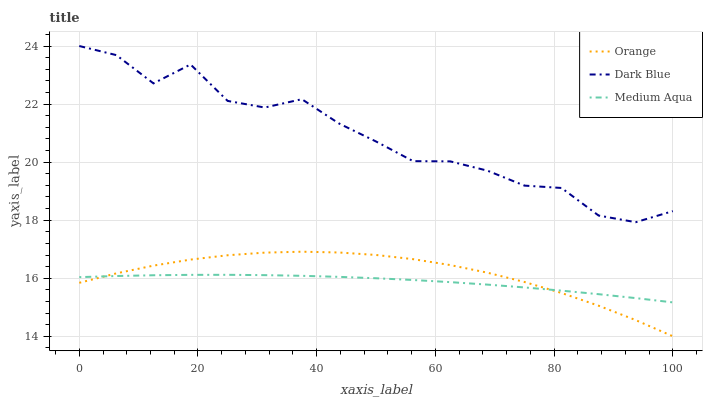Does Medium Aqua have the minimum area under the curve?
Answer yes or no. Yes. Does Dark Blue have the maximum area under the curve?
Answer yes or no. Yes. Does Dark Blue have the minimum area under the curve?
Answer yes or no. No. Does Medium Aqua have the maximum area under the curve?
Answer yes or no. No. Is Medium Aqua the smoothest?
Answer yes or no. Yes. Is Dark Blue the roughest?
Answer yes or no. Yes. Is Dark Blue the smoothest?
Answer yes or no. No. Is Medium Aqua the roughest?
Answer yes or no. No. Does Orange have the lowest value?
Answer yes or no. Yes. Does Medium Aqua have the lowest value?
Answer yes or no. No. Does Dark Blue have the highest value?
Answer yes or no. Yes. Does Medium Aqua have the highest value?
Answer yes or no. No. Is Medium Aqua less than Dark Blue?
Answer yes or no. Yes. Is Dark Blue greater than Orange?
Answer yes or no. Yes. Does Medium Aqua intersect Orange?
Answer yes or no. Yes. Is Medium Aqua less than Orange?
Answer yes or no. No. Is Medium Aqua greater than Orange?
Answer yes or no. No. Does Medium Aqua intersect Dark Blue?
Answer yes or no. No. 